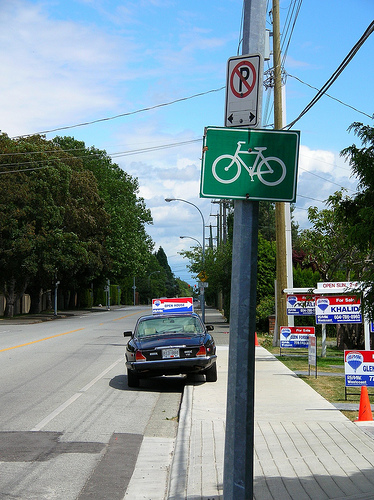<image>
Can you confirm if the car is on the sidewalk? Yes. Looking at the image, I can see the car is positioned on top of the sidewalk, with the sidewalk providing support. 